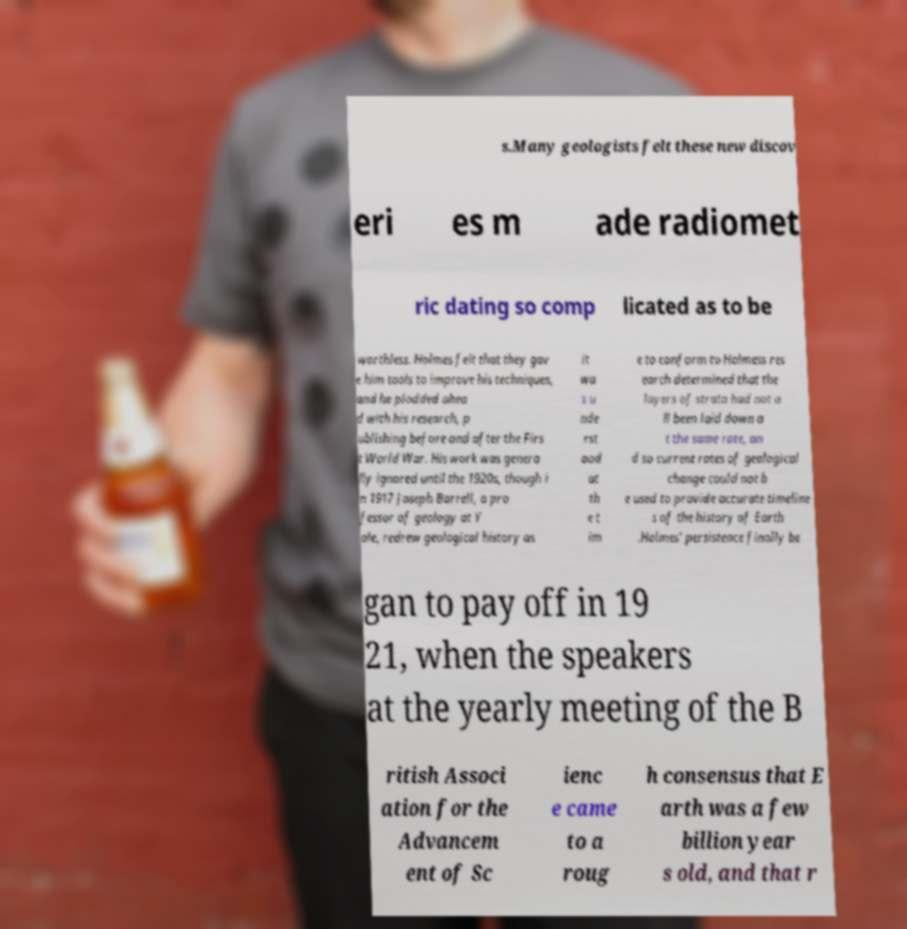Can you read and provide the text displayed in the image?This photo seems to have some interesting text. Can you extract and type it out for me? s.Many geologists felt these new discov eri es m ade radiomet ric dating so comp licated as to be worthless. Holmes felt that they gav e him tools to improve his techniques, and he plodded ahea d with his research, p ublishing before and after the Firs t World War. His work was genera lly ignored until the 1920s, though i n 1917 Joseph Barrell, a pro fessor of geology at Y ale, redrew geological history as it wa s u nde rst ood at th e t im e to conform to Holmess res earch determined that the layers of strata had not a ll been laid down a t the same rate, an d so current rates of geological change could not b e used to provide accurate timeline s of the history of Earth .Holmes' persistence finally be gan to pay off in 19 21, when the speakers at the yearly meeting of the B ritish Associ ation for the Advancem ent of Sc ienc e came to a roug h consensus that E arth was a few billion year s old, and that r 